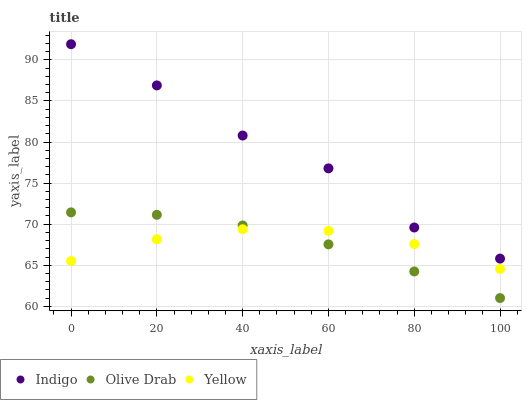Does Olive Drab have the minimum area under the curve?
Answer yes or no. Yes. Does Indigo have the maximum area under the curve?
Answer yes or no. Yes. Does Yellow have the minimum area under the curve?
Answer yes or no. No. Does Yellow have the maximum area under the curve?
Answer yes or no. No. Is Olive Drab the smoothest?
Answer yes or no. Yes. Is Indigo the roughest?
Answer yes or no. Yes. Is Yellow the smoothest?
Answer yes or no. No. Is Yellow the roughest?
Answer yes or no. No. Does Olive Drab have the lowest value?
Answer yes or no. Yes. Does Yellow have the lowest value?
Answer yes or no. No. Does Indigo have the highest value?
Answer yes or no. Yes. Does Olive Drab have the highest value?
Answer yes or no. No. Is Olive Drab less than Indigo?
Answer yes or no. Yes. Is Indigo greater than Yellow?
Answer yes or no. Yes. Does Olive Drab intersect Yellow?
Answer yes or no. Yes. Is Olive Drab less than Yellow?
Answer yes or no. No. Is Olive Drab greater than Yellow?
Answer yes or no. No. Does Olive Drab intersect Indigo?
Answer yes or no. No. 